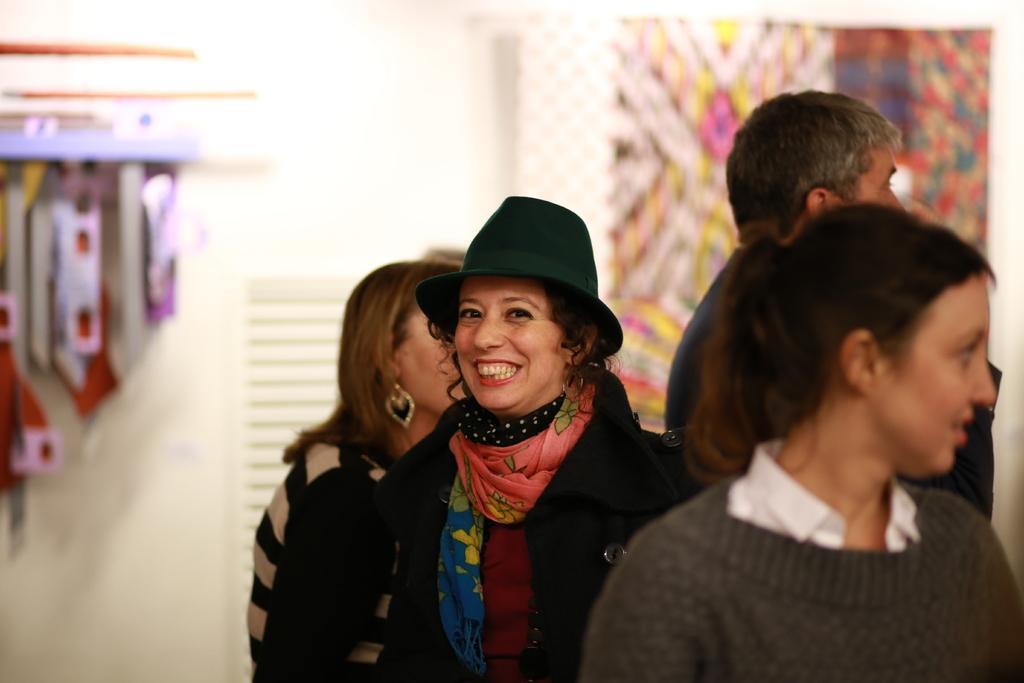In one or two sentences, can you explain what this image depicts? In this image I can see group of people standing. The person in front wearing black jacket, maroon shirt, orange and blue color scarf. Background I can see a wall in white color. 